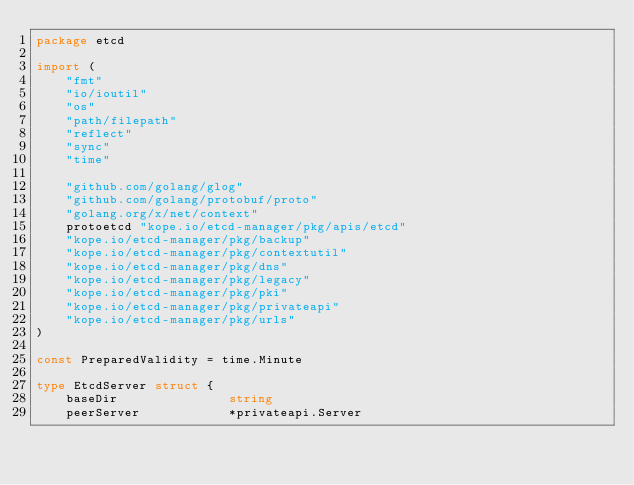Convert code to text. <code><loc_0><loc_0><loc_500><loc_500><_Go_>package etcd

import (
	"fmt"
	"io/ioutil"
	"os"
	"path/filepath"
	"reflect"
	"sync"
	"time"

	"github.com/golang/glog"
	"github.com/golang/protobuf/proto"
	"golang.org/x/net/context"
	protoetcd "kope.io/etcd-manager/pkg/apis/etcd"
	"kope.io/etcd-manager/pkg/backup"
	"kope.io/etcd-manager/pkg/contextutil"
	"kope.io/etcd-manager/pkg/dns"
	"kope.io/etcd-manager/pkg/legacy"
	"kope.io/etcd-manager/pkg/pki"
	"kope.io/etcd-manager/pkg/privateapi"
	"kope.io/etcd-manager/pkg/urls"
)

const PreparedValidity = time.Minute

type EtcdServer struct {
	baseDir               string
	peerServer            *privateapi.Server</code> 